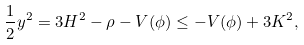Convert formula to latex. <formula><loc_0><loc_0><loc_500><loc_500>\frac { 1 } { 2 } y ^ { 2 } = 3 H ^ { 2 } - \rho - V ( \phi ) \leq - V ( \phi ) + 3 K ^ { 2 } ,</formula> 